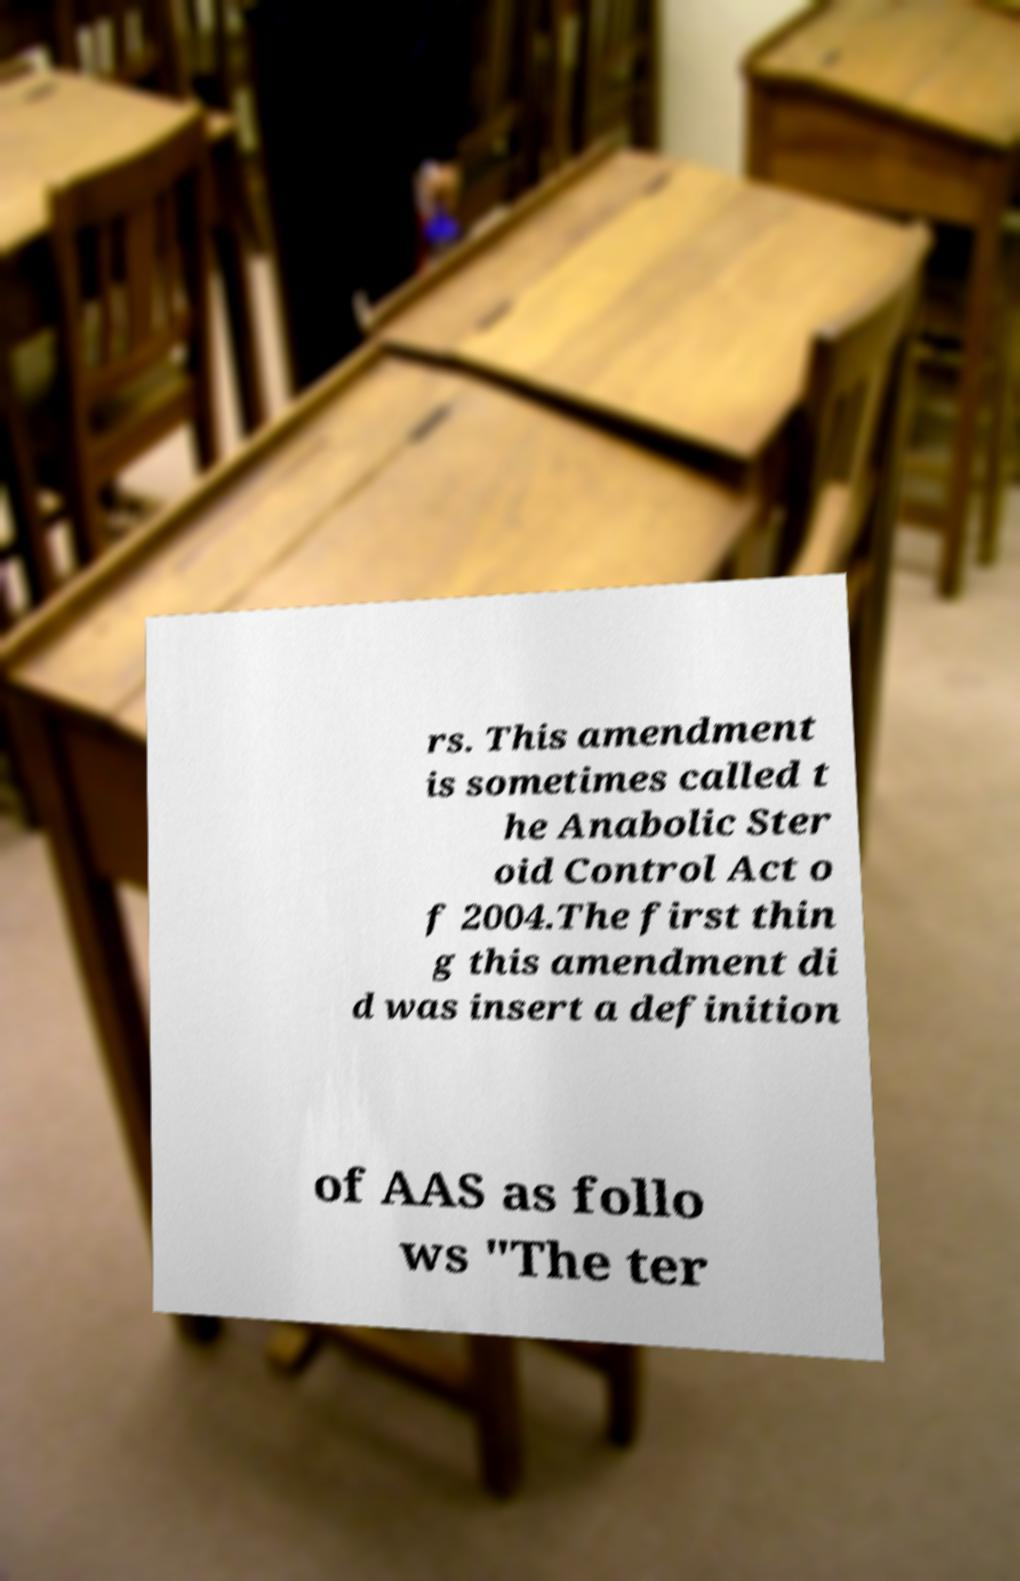Can you read and provide the text displayed in the image?This photo seems to have some interesting text. Can you extract and type it out for me? rs. This amendment is sometimes called t he Anabolic Ster oid Control Act o f 2004.The first thin g this amendment di d was insert a definition of AAS as follo ws "The ter 